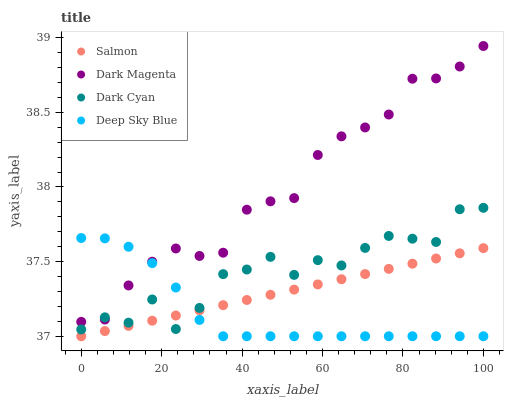Does Deep Sky Blue have the minimum area under the curve?
Answer yes or no. Yes. Does Dark Magenta have the maximum area under the curve?
Answer yes or no. Yes. Does Salmon have the minimum area under the curve?
Answer yes or no. No. Does Salmon have the maximum area under the curve?
Answer yes or no. No. Is Salmon the smoothest?
Answer yes or no. Yes. Is Dark Cyan the roughest?
Answer yes or no. Yes. Is Dark Magenta the smoothest?
Answer yes or no. No. Is Dark Magenta the roughest?
Answer yes or no. No. Does Salmon have the lowest value?
Answer yes or no. Yes. Does Dark Magenta have the lowest value?
Answer yes or no. No. Does Dark Magenta have the highest value?
Answer yes or no. Yes. Does Salmon have the highest value?
Answer yes or no. No. Is Salmon less than Dark Magenta?
Answer yes or no. Yes. Is Dark Magenta greater than Salmon?
Answer yes or no. Yes. Does Dark Cyan intersect Dark Magenta?
Answer yes or no. Yes. Is Dark Cyan less than Dark Magenta?
Answer yes or no. No. Is Dark Cyan greater than Dark Magenta?
Answer yes or no. No. Does Salmon intersect Dark Magenta?
Answer yes or no. No. 